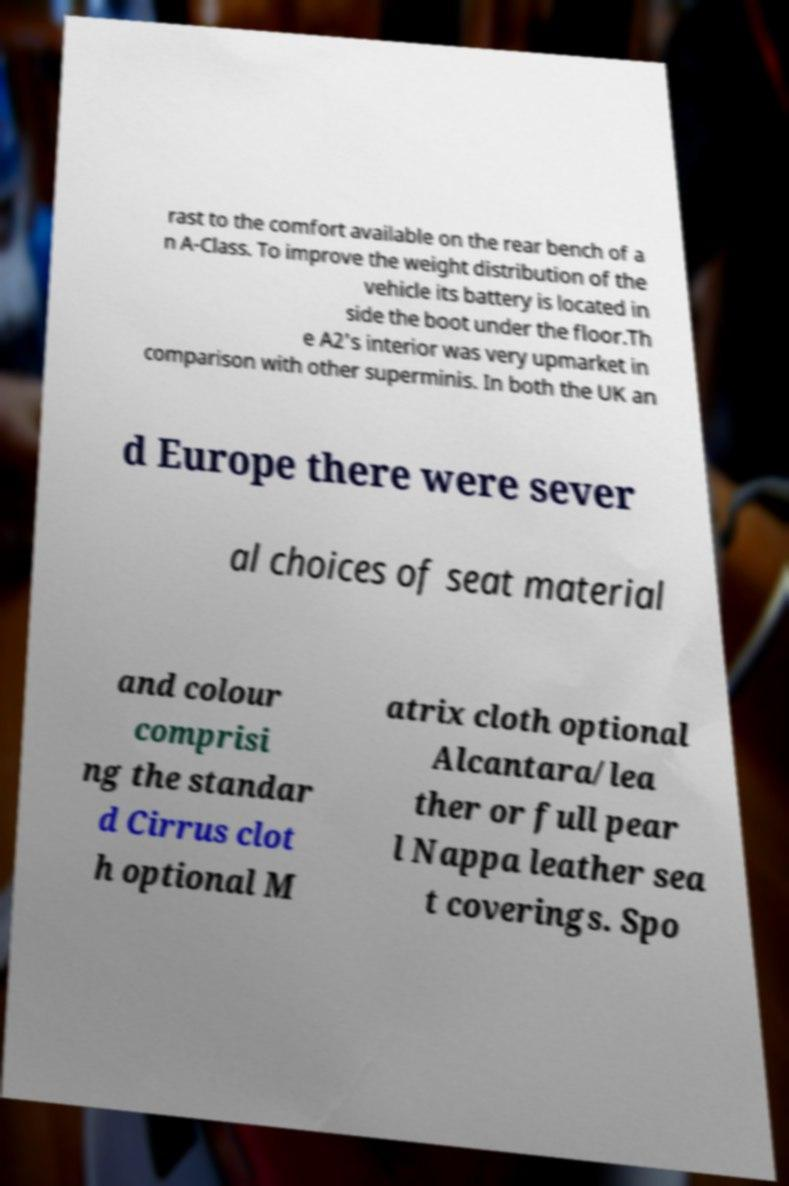There's text embedded in this image that I need extracted. Can you transcribe it verbatim? rast to the comfort available on the rear bench of a n A-Class. To improve the weight distribution of the vehicle its battery is located in side the boot under the floor.Th e A2's interior was very upmarket in comparison with other superminis. In both the UK an d Europe there were sever al choices of seat material and colour comprisi ng the standar d Cirrus clot h optional M atrix cloth optional Alcantara/lea ther or full pear l Nappa leather sea t coverings. Spo 